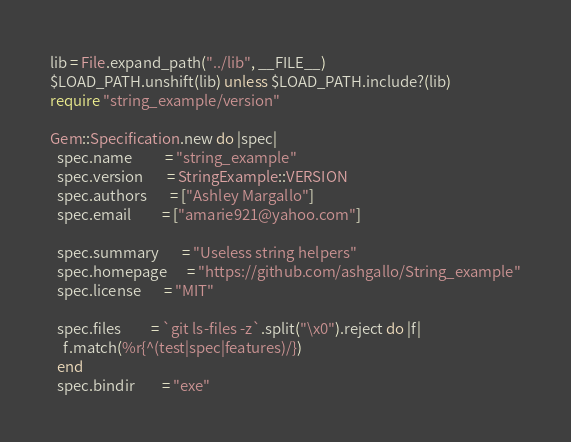Convert code to text. <code><loc_0><loc_0><loc_500><loc_500><_Ruby_>
lib = File.expand_path("../lib", __FILE__)
$LOAD_PATH.unshift(lib) unless $LOAD_PATH.include?(lib)
require "string_example/version"

Gem::Specification.new do |spec|
  spec.name          = "string_example"
  spec.version       = StringExample::VERSION
  spec.authors       = ["Ashley Margallo"]
  spec.email         = ["amarie921@yahoo.com"]

  spec.summary       = "Useless string helpers"
  spec.homepage      = "https://github.com/ashgallo/String_example"
  spec.license       = "MIT"

  spec.files         = `git ls-files -z`.split("\x0").reject do |f|
    f.match(%r{^(test|spec|features)/})
  end
  spec.bindir        = "exe"</code> 